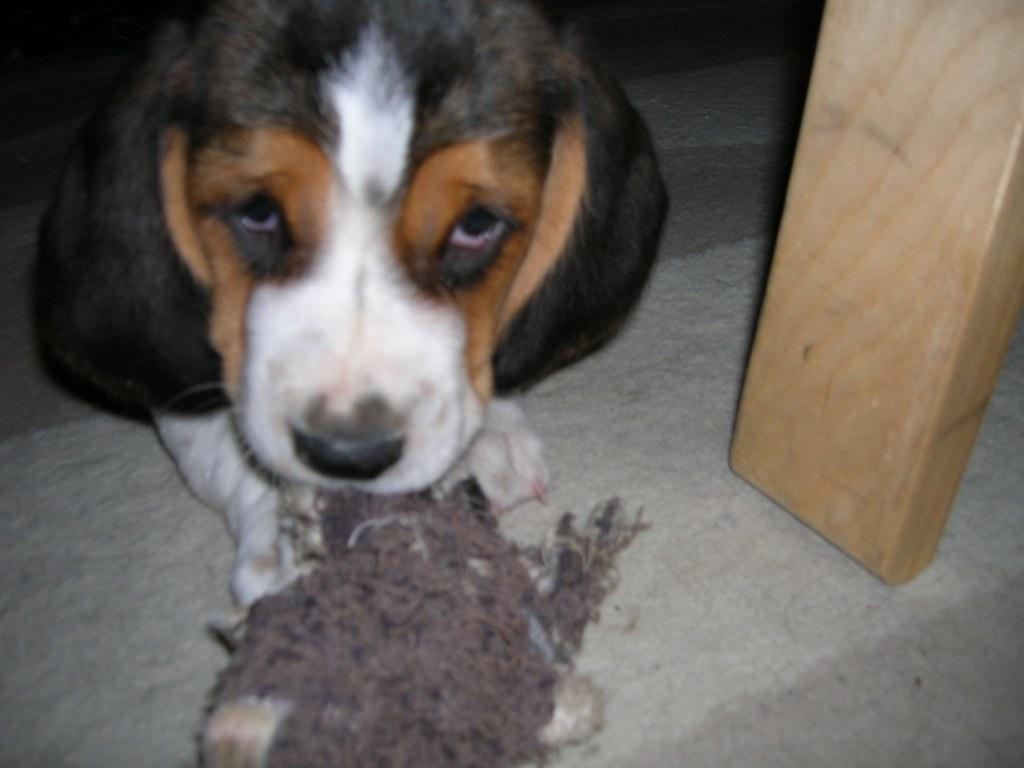What is the main subject of the image? There is a dog in the center of the image. Where is the dog located? The dog is on the floor. What is in front of the dog? There is an object in front of the dog. What type of object can be seen on the right side of the image? There is a wooden object on the right side of the image. What color is the paint on the thrill ride in the image? There is no paint or thrill ride present in the image; it features a dog on the floor with an object in front of it and a wooden object on the right side. 